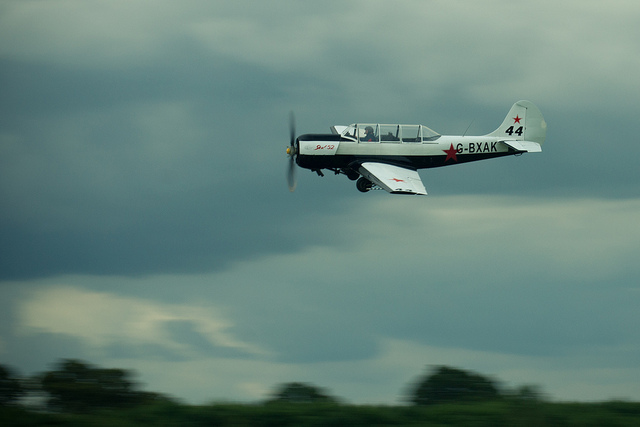Read all the text in this image. 44 G BXAK 52 